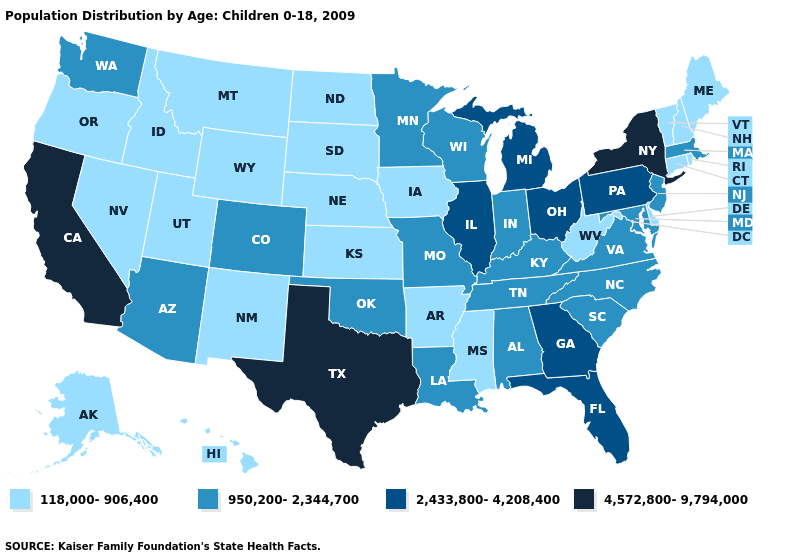What is the lowest value in the South?
Write a very short answer. 118,000-906,400. What is the value of Vermont?
Give a very brief answer. 118,000-906,400. Name the states that have a value in the range 2,433,800-4,208,400?
Short answer required. Florida, Georgia, Illinois, Michigan, Ohio, Pennsylvania. Does Kansas have the lowest value in the USA?
Quick response, please. Yes. Name the states that have a value in the range 118,000-906,400?
Keep it brief. Alaska, Arkansas, Connecticut, Delaware, Hawaii, Idaho, Iowa, Kansas, Maine, Mississippi, Montana, Nebraska, Nevada, New Hampshire, New Mexico, North Dakota, Oregon, Rhode Island, South Dakota, Utah, Vermont, West Virginia, Wyoming. Does New Mexico have the same value as New Hampshire?
Write a very short answer. Yes. Which states have the highest value in the USA?
Write a very short answer. California, New York, Texas. What is the highest value in states that border Maine?
Quick response, please. 118,000-906,400. What is the lowest value in the MidWest?
Concise answer only. 118,000-906,400. What is the lowest value in states that border New Mexico?
Short answer required. 118,000-906,400. What is the value of New York?
Short answer required. 4,572,800-9,794,000. What is the highest value in the West ?
Concise answer only. 4,572,800-9,794,000. Which states have the lowest value in the MidWest?
Concise answer only. Iowa, Kansas, Nebraska, North Dakota, South Dakota. Among the states that border Florida , which have the lowest value?
Concise answer only. Alabama. Which states have the highest value in the USA?
Quick response, please. California, New York, Texas. 